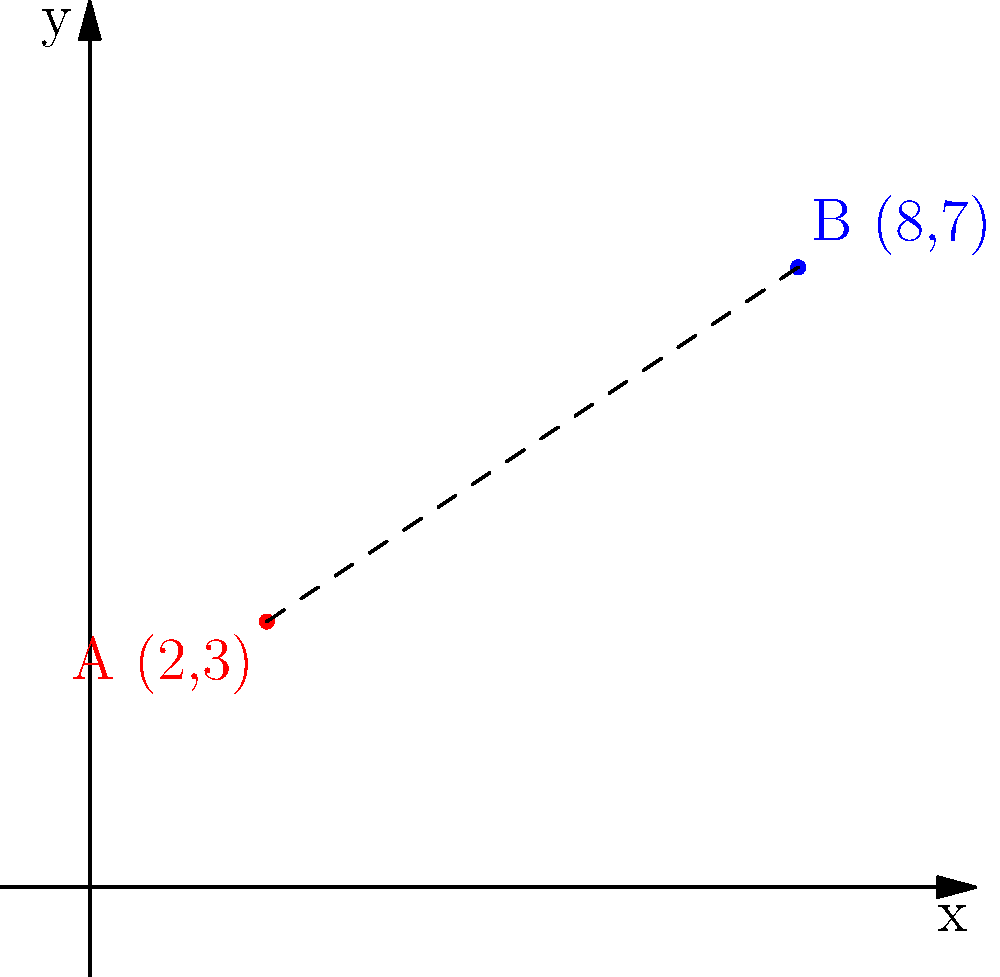Your niece claims that Instagram celebrity A is "so far away" from celebrity B on her feed. On this simplified Instagram grid, celebrity A is at point (2,3) and celebrity B is at point (8,7). Calculate the actual distance between these two celebrities' posts using the distance formula. Round your answer to two decimal places. To find the distance between two points on a coordinate plane, we use the distance formula:

$$d = \sqrt{(x_2-x_1)^2 + (y_2-y_1)^2}$$

Where $(x_1,y_1)$ is the coordinate of the first point and $(x_2,y_2)$ is the coordinate of the second point.

Given:
Point A (celebrity A): $(2,3)$
Point B (celebrity B): $(8,7)$

Step 1: Identify the coordinates
$x_1 = 2$, $y_1 = 3$
$x_2 = 8$, $y_2 = 7$

Step 2: Plug the values into the distance formula
$$d = \sqrt{(8-2)^2 + (7-3)^2}$$

Step 3: Simplify the expressions inside the parentheses
$$d = \sqrt{6^2 + 4^2}$$

Step 4: Calculate the squares
$$d = \sqrt{36 + 16}$$

Step 5: Add the values under the square root
$$d = \sqrt{52}$$

Step 6: Simplify the square root
$$d = 2\sqrt{13} \approx 7.21$$

Step 7: Round to two decimal places
$$d \approx 7.21$$

Therefore, the distance between the two celebrities' posts is approximately 7.21 units on the Instagram grid.
Answer: 7.21 units 